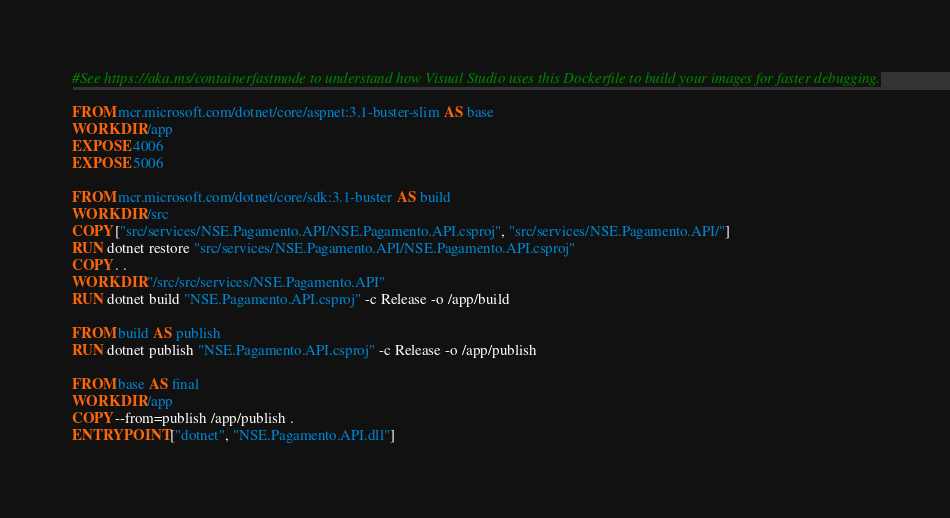Convert code to text. <code><loc_0><loc_0><loc_500><loc_500><_Dockerfile_>#See https://aka.ms/containerfastmode to understand how Visual Studio uses this Dockerfile to build your images for faster debugging.

FROM mcr.microsoft.com/dotnet/core/aspnet:3.1-buster-slim AS base
WORKDIR /app
EXPOSE 4006
EXPOSE 5006

FROM mcr.microsoft.com/dotnet/core/sdk:3.1-buster AS build
WORKDIR /src
COPY ["src/services/NSE.Pagamento.API/NSE.Pagamento.API.csproj", "src/services/NSE.Pagamento.API/"]
RUN dotnet restore "src/services/NSE.Pagamento.API/NSE.Pagamento.API.csproj"
COPY . .
WORKDIR "/src/src/services/NSE.Pagamento.API"
RUN dotnet build "NSE.Pagamento.API.csproj" -c Release -o /app/build

FROM build AS publish
RUN dotnet publish "NSE.Pagamento.API.csproj" -c Release -o /app/publish

FROM base AS final
WORKDIR /app
COPY --from=publish /app/publish .
ENTRYPOINT ["dotnet", "NSE.Pagamento.API.dll"]</code> 